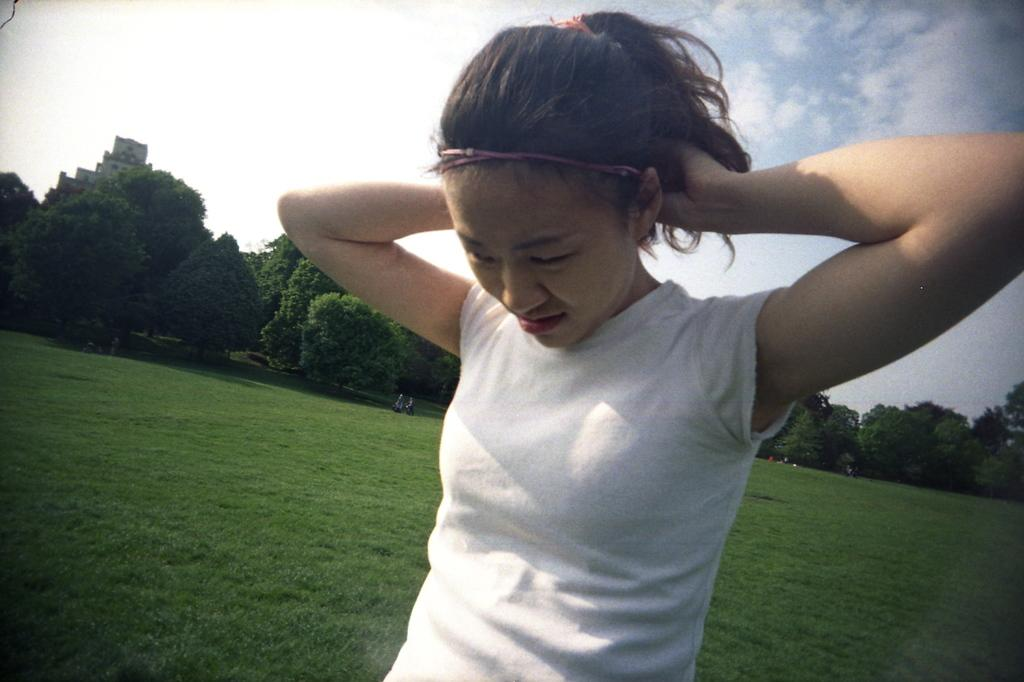What is the main subject in the middle of the image? There is a woman standing in the middle of the image. What type of terrain is visible behind the woman? There is grass behind the woman. What can be seen in the distance in the image? There are trees visible in the background. What is visible at the top of the image? There are clouds and the sky visible at the top of the image. Can you see the cast of the latest Broadway show in the image? There is no reference to a Broadway show or any cast in the image, so it is not possible to determine if they are present. 